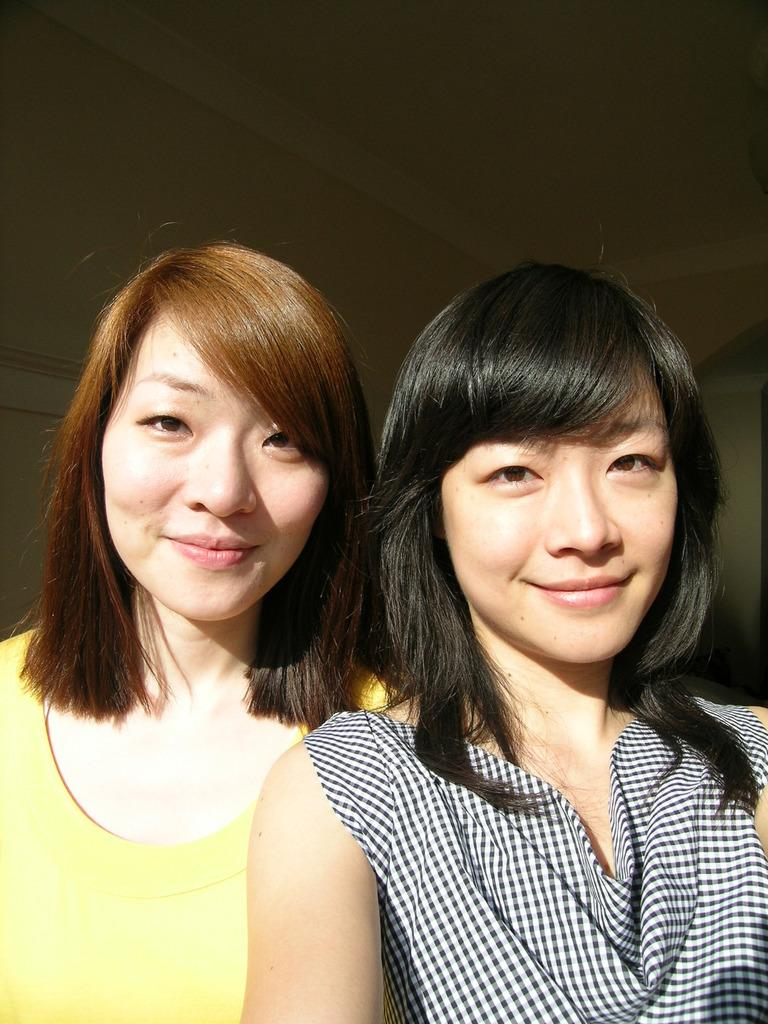How many people are in the image? There are two people in the image. What colors are the people wearing? The people are wearing yellow, white, and black color dress. What can be seen in the background of the image? There is a wall in the background of the image. What type of joke is the person on the left telling in the image? There is no indication of a joke being told in the image, as the focus is on the people's clothing and the wall in the background. 